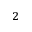<formula> <loc_0><loc_0><loc_500><loc_500>_ { 2 }</formula> 